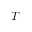<formula> <loc_0><loc_0><loc_500><loc_500>T</formula> 